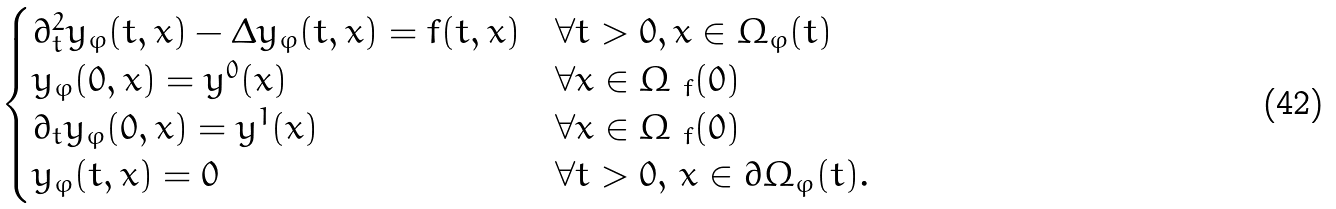<formula> <loc_0><loc_0><loc_500><loc_500>\begin{cases} \partial _ { t } ^ { 2 } y _ { \varphi } ( t , x ) - \Delta y _ { \varphi } ( t , x ) = f ( t , x ) & \forall t > 0 , x \in \Omega _ { \varphi } ( t ) \\ y _ { \varphi } ( 0 , x ) = y ^ { 0 } ( x ) & \forall x \in \Omega _ { \ f } ( 0 ) \\ \partial _ { t } y _ { \varphi } ( 0 , x ) = y ^ { 1 } ( x ) & \forall x \in \Omega _ { \ f } ( 0 ) \\ y _ { \varphi } ( t , x ) = 0 & \forall t > 0 , \, x \in \partial \Omega _ { \varphi } ( t ) . \end{cases}</formula> 